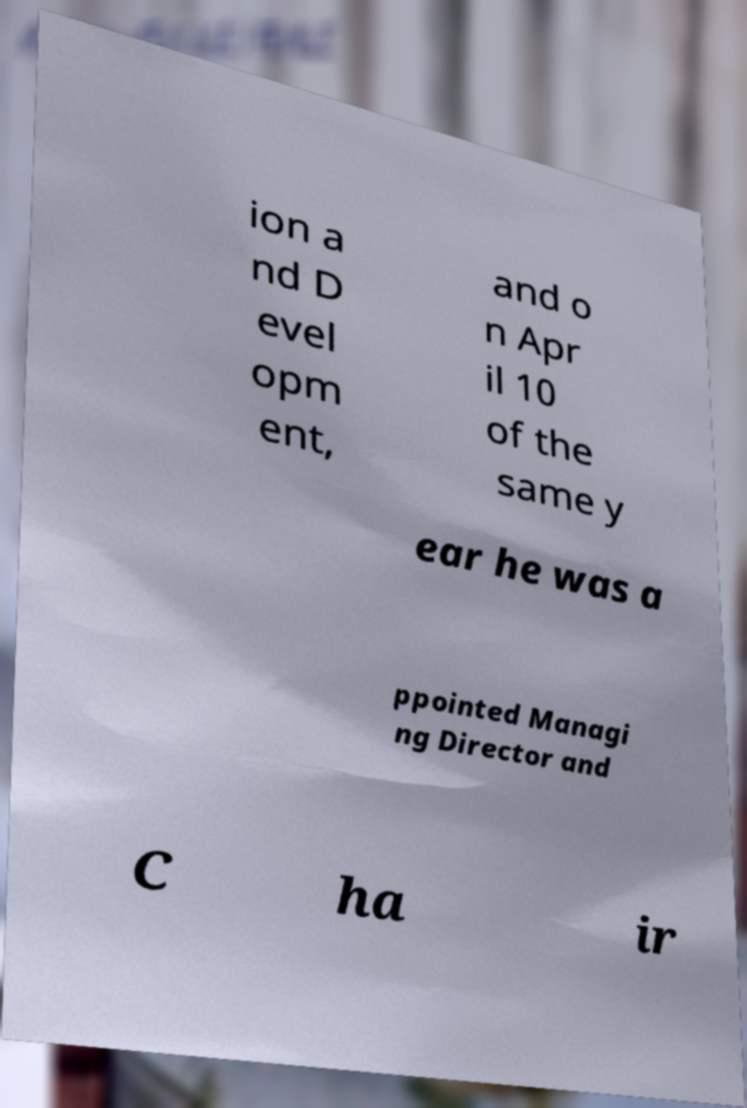There's text embedded in this image that I need extracted. Can you transcribe it verbatim? ion a nd D evel opm ent, and o n Apr il 10 of the same y ear he was a ppointed Managi ng Director and C ha ir 